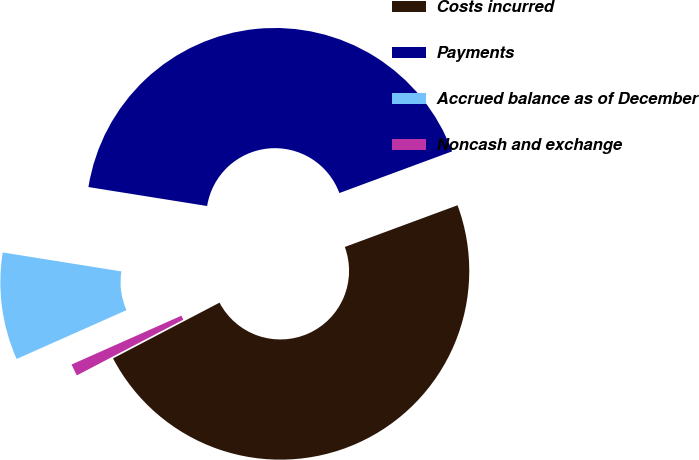Convert chart to OTSL. <chart><loc_0><loc_0><loc_500><loc_500><pie_chart><fcel>Costs incurred<fcel>Payments<fcel>Accrued balance as of December<fcel>Noncash and exchange<nl><fcel>47.96%<fcel>41.84%<fcel>9.18%<fcel>1.02%<nl></chart> 